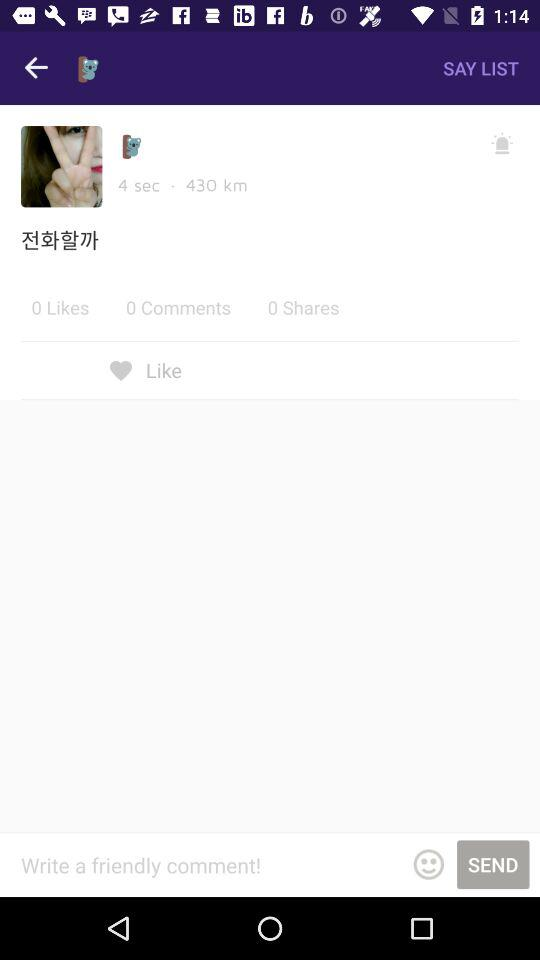How many likes are there? There are 0 likes. 